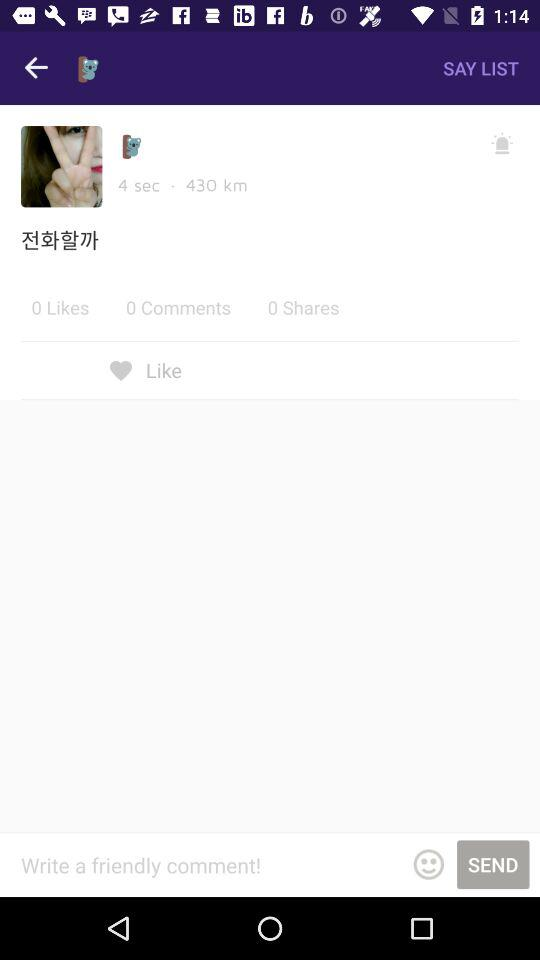How many likes are there? There are 0 likes. 